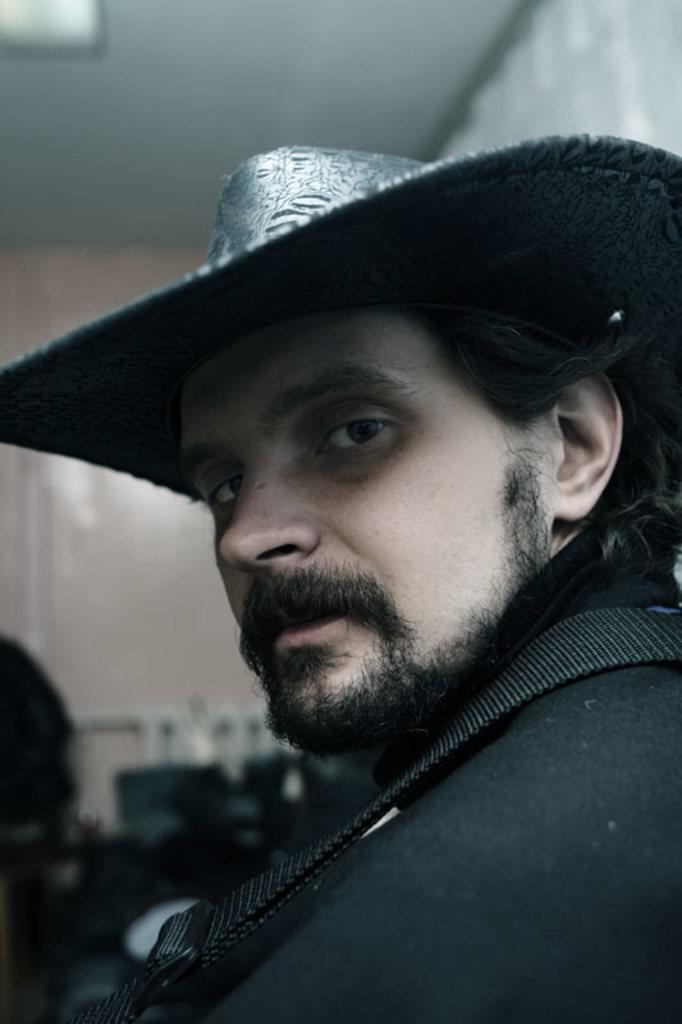What is the main subject in the foreground of the image? There is a person in the foreground of the image. What is the person wearing on their head? The person is wearing a hat. What can be seen in the background of the image? There are objects and a wall in the background of the image. What is visible at the top of the image? The ceiling is visible at the top of the image. What type of eggnog is being served in the image? There is no eggnog present in the image. What is the person experiencing a loss of in the image? There is no indication of loss or any related context in the image. 